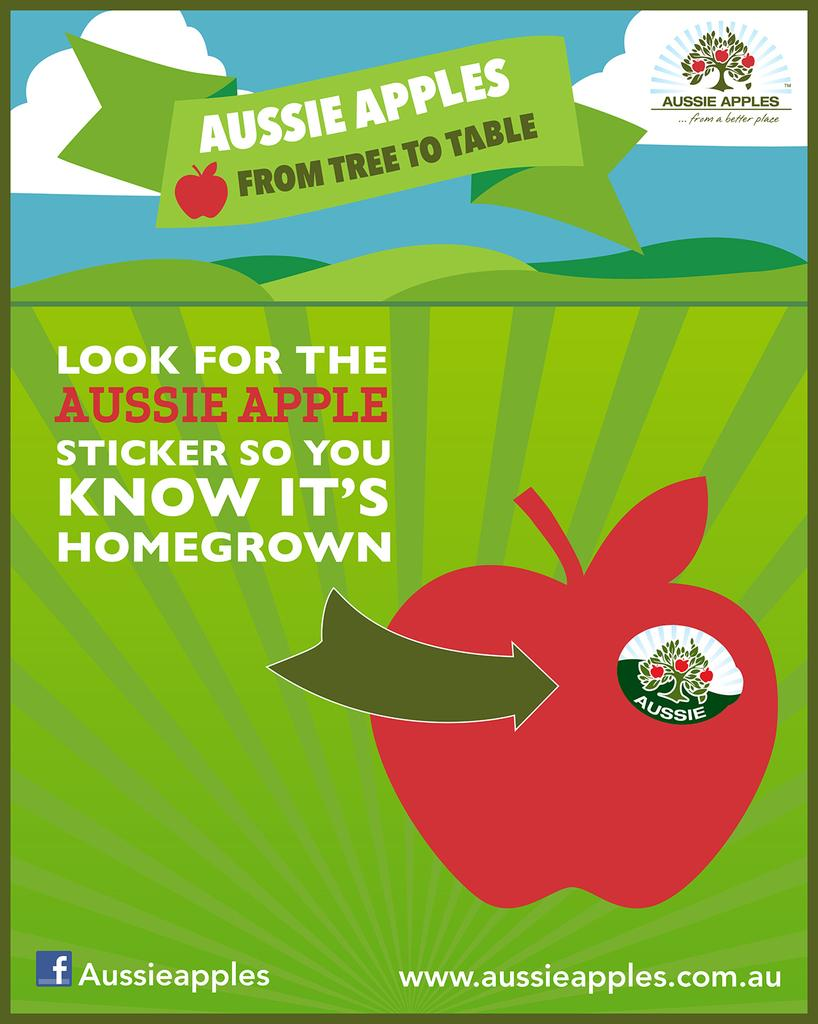What is present on the poster in the image? There is a poster in the image that contains symbols and text. Can you describe the symbols on the poster? Unfortunately, the specific symbols on the poster cannot be described without more information. What type of information is conveyed through the text on the poster? The content of the text on the poster cannot be determined without more information. What type of nut is being used to stir the liquid in the image? There is no nut or liquid present in the image; it only features a poster with symbols and text. 